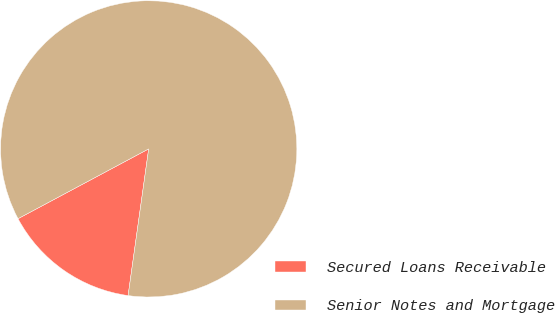Convert chart to OTSL. <chart><loc_0><loc_0><loc_500><loc_500><pie_chart><fcel>Secured Loans Receivable<fcel>Senior Notes and Mortgage<nl><fcel>14.97%<fcel>85.03%<nl></chart> 